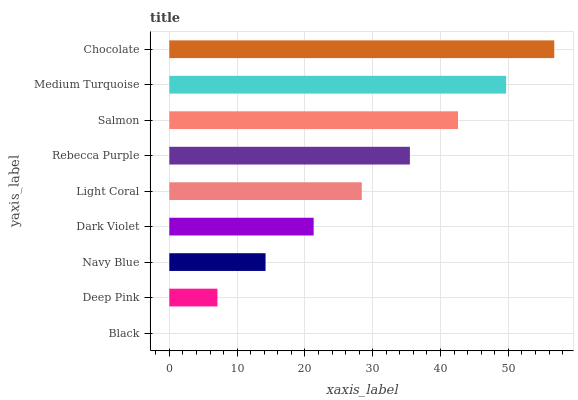Is Black the minimum?
Answer yes or no. Yes. Is Chocolate the maximum?
Answer yes or no. Yes. Is Deep Pink the minimum?
Answer yes or no. No. Is Deep Pink the maximum?
Answer yes or no. No. Is Deep Pink greater than Black?
Answer yes or no. Yes. Is Black less than Deep Pink?
Answer yes or no. Yes. Is Black greater than Deep Pink?
Answer yes or no. No. Is Deep Pink less than Black?
Answer yes or no. No. Is Light Coral the high median?
Answer yes or no. Yes. Is Light Coral the low median?
Answer yes or no. Yes. Is Navy Blue the high median?
Answer yes or no. No. Is Deep Pink the low median?
Answer yes or no. No. 